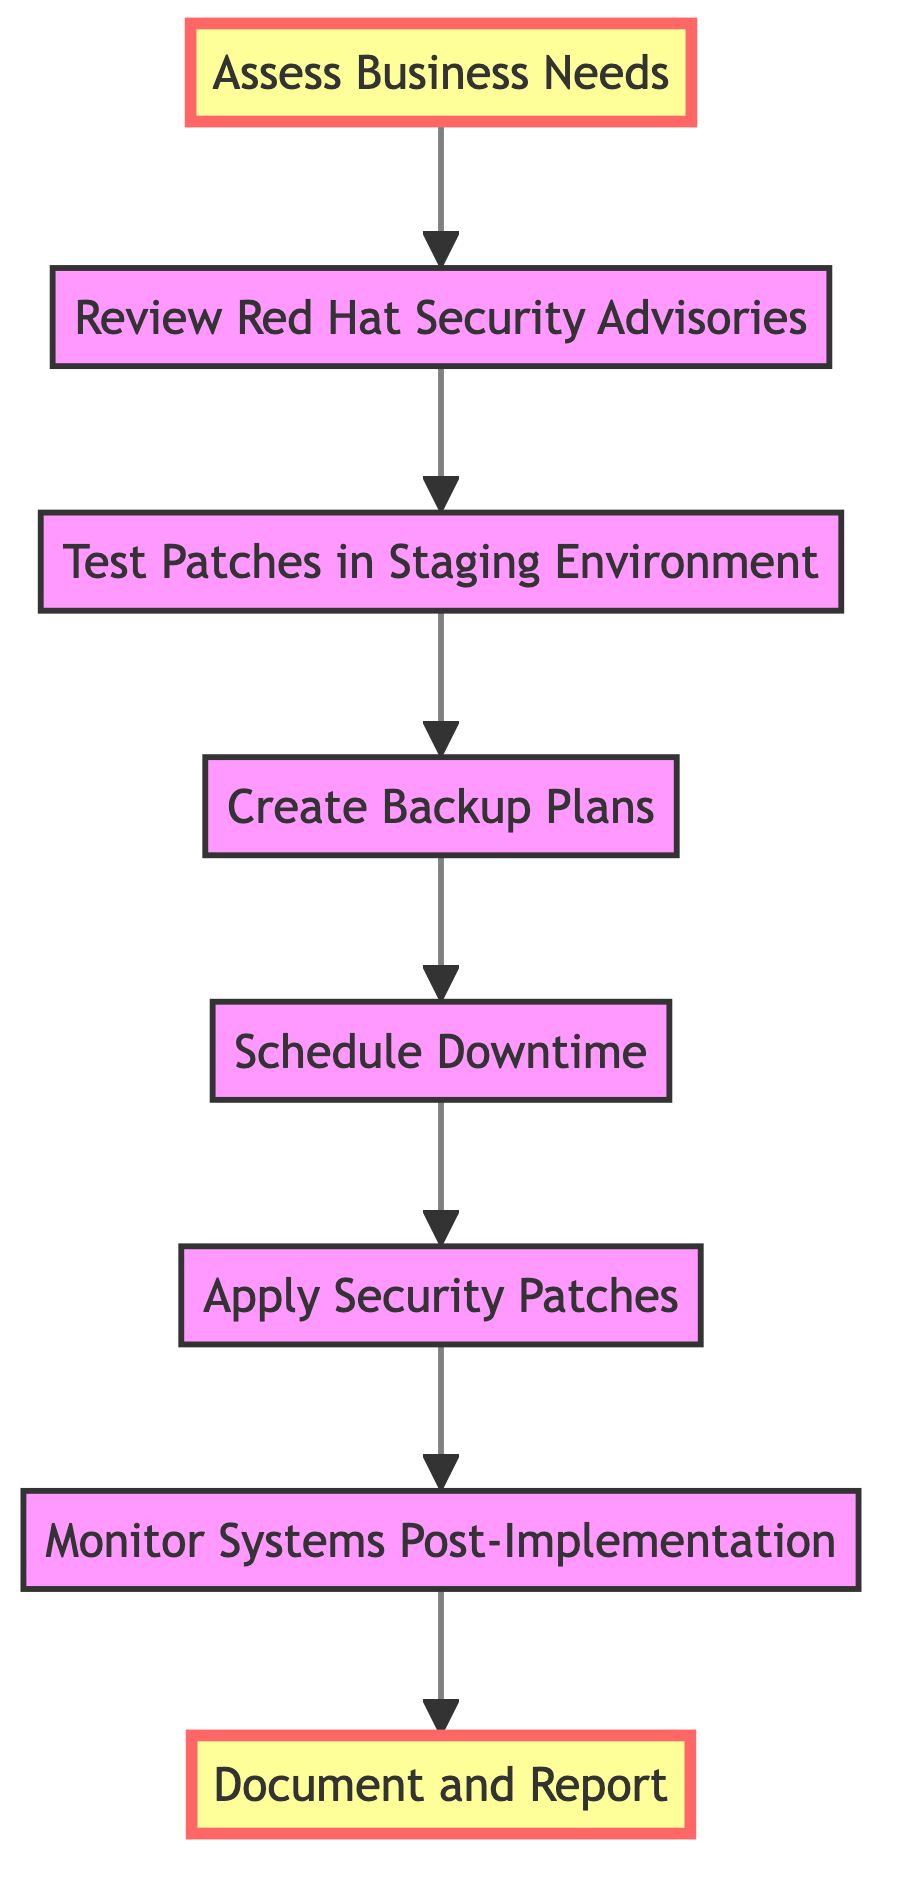What is the first step in the diagram? The diagram starts with the first node labeled "Assess Business Needs," indicating it is the initial action to begin the process.
Answer: Assess Business Needs What is the last step in the diagram? The final node in the flow is "Document and Report," which indicates that this is the concluding action after all previous steps have been completed.
Answer: Document and Report How many total steps are in the flow chart? Counting each of the individual steps listed from 1 to 8, there are a total of eight steps represented in the diagram.
Answer: Eight Which step follows "Test Patches in Staging Environment"? The flow indicates that after "Test Patches in Staging Environment," the next step is "Create Backup Plans," establishing the direct relationship between these two nodes.
Answer: Create Backup Plans What is the relationship between "Apply Security Patches" and "Monitor Systems Post-Implementation"? The arrow in the diagram shows that "Apply Security Patches" leads directly to "Monitor Systems Post-Implementation," indicating that monitoring is essential after applying the patches.
Answer: Leads directly to What are the crucial actions before applying the patches? The diagram indicates that "Create Backup Plans" and "Schedule Downtime" are the required actions that must occur before the actual application of the patches takes place, as they are presented just prior to the "Apply Security Patches" step.
Answer: Create Backup Plans, Schedule Downtime How does the diagram flow from the bottom to the top? The arrows connecting each step in the flow chart clearly demonstrate that the actions progress upward, moving from initial assessments at the bottom to documentation at the top, reflecting a continuous process that starts with evaluation and ends with reporting.
Answer: Upward Which step emphasizes stakeholder communication? The last node, "Document and Report," highlights the importance of keeping stakeholders informed about the patched systems and any updates, as it specifically mentions reporting to stakeholders.
Answer: Document and Report 